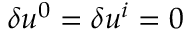Convert formula to latex. <formula><loc_0><loc_0><loc_500><loc_500>\delta u ^ { 0 } = \delta u ^ { i } = 0</formula> 